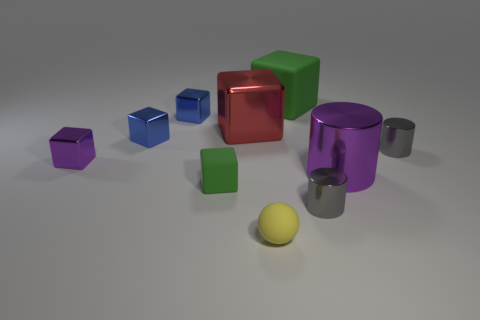What is the material of the small block that is the same color as the big rubber thing?
Provide a short and direct response. Rubber. What number of objects are either big cubes to the right of the yellow rubber thing or small blue objects?
Your answer should be compact. 3. Does the green thing right of the yellow object have the same size as the large purple cylinder?
Your answer should be very brief. Yes. Is the number of big green matte things that are in front of the large matte object less than the number of small purple shiny things?
Offer a terse response. Yes. There is a green block that is the same size as the yellow rubber ball; what is its material?
Make the answer very short. Rubber. How many small things are either matte spheres or green rubber cubes?
Make the answer very short. 2. What number of things are either small purple metal objects that are in front of the big red thing or tiny blue shiny cubes to the right of the purple metallic cube?
Provide a succinct answer. 3. Is the number of red shiny objects less than the number of tiny cyan metallic cubes?
Offer a very short reply. No. What shape is the purple shiny thing that is the same size as the yellow rubber sphere?
Your response must be concise. Cube. How many other things are there of the same color as the tiny rubber sphere?
Offer a terse response. 0. 